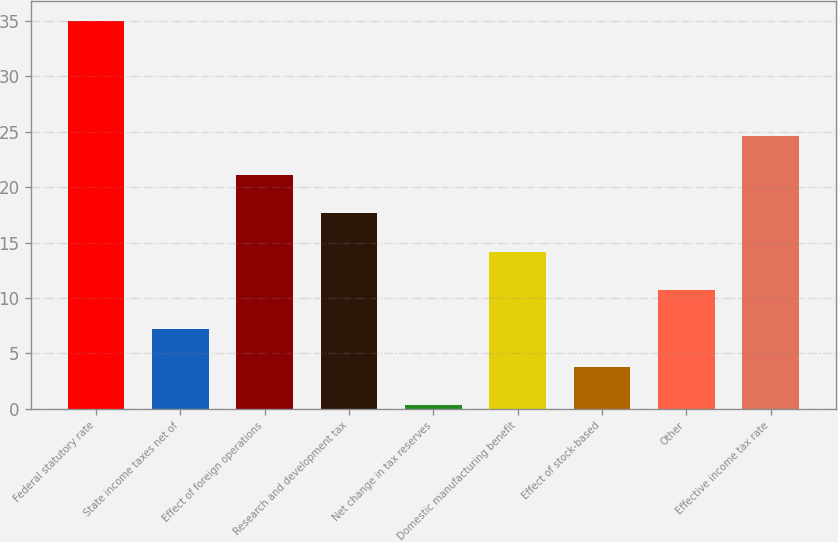Convert chart to OTSL. <chart><loc_0><loc_0><loc_500><loc_500><bar_chart><fcel>Federal statutory rate<fcel>State income taxes net of<fcel>Effect of foreign operations<fcel>Research and development tax<fcel>Net change in tax reserves<fcel>Domestic manufacturing benefit<fcel>Effect of stock-based<fcel>Other<fcel>Effective income tax rate<nl><fcel>35<fcel>7.24<fcel>21.12<fcel>17.65<fcel>0.3<fcel>14.18<fcel>3.77<fcel>10.71<fcel>24.59<nl></chart> 